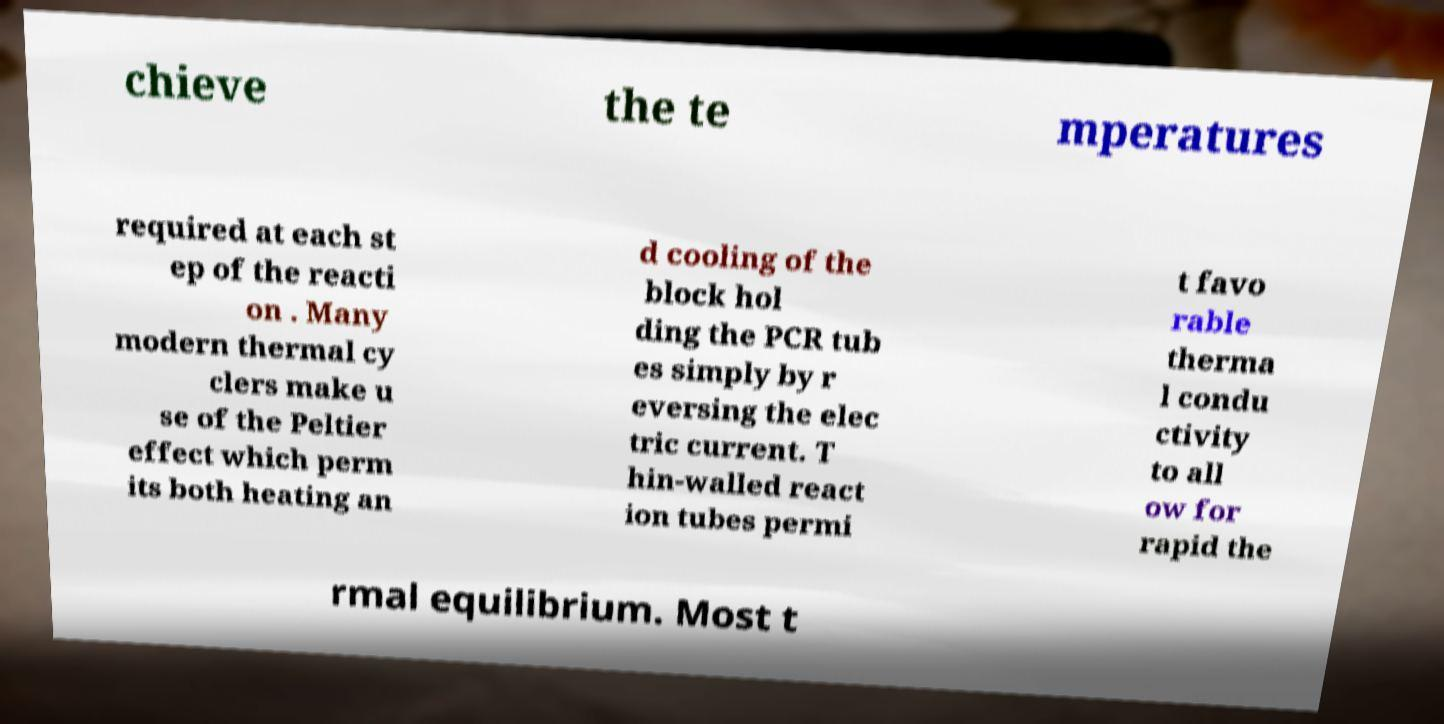There's text embedded in this image that I need extracted. Can you transcribe it verbatim? chieve the te mperatures required at each st ep of the reacti on . Many modern thermal cy clers make u se of the Peltier effect which perm its both heating an d cooling of the block hol ding the PCR tub es simply by r eversing the elec tric current. T hin-walled react ion tubes permi t favo rable therma l condu ctivity to all ow for rapid the rmal equilibrium. Most t 